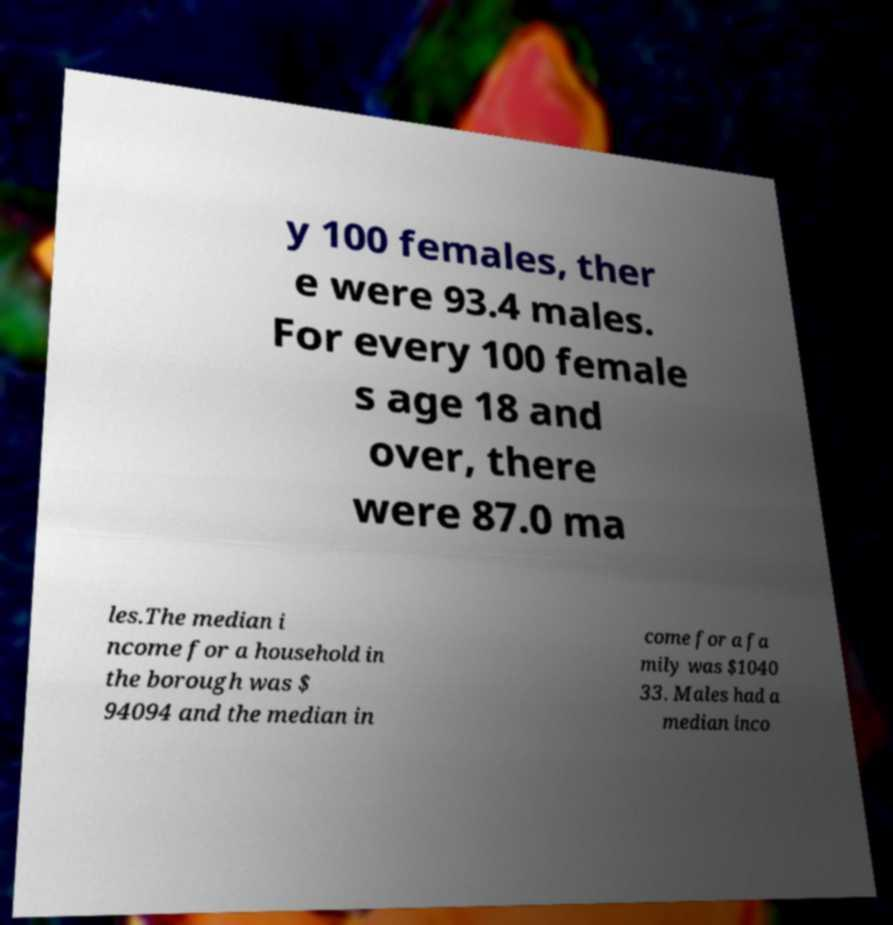Could you assist in decoding the text presented in this image and type it out clearly? y 100 females, ther e were 93.4 males. For every 100 female s age 18 and over, there were 87.0 ma les.The median i ncome for a household in the borough was $ 94094 and the median in come for a fa mily was $1040 33. Males had a median inco 